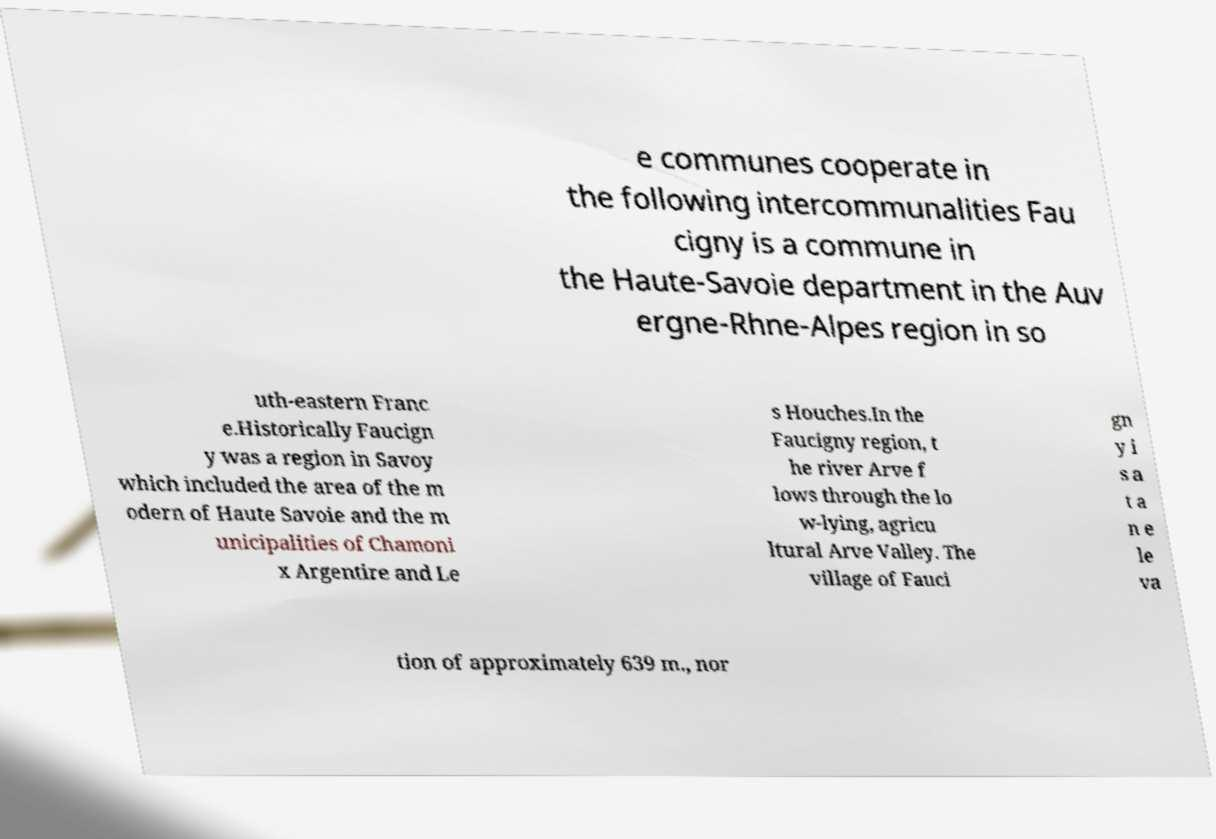Could you extract and type out the text from this image? e communes cooperate in the following intercommunalities Fau cigny is a commune in the Haute-Savoie department in the Auv ergne-Rhne-Alpes region in so uth-eastern Franc e.Historically Faucign y was a region in Savoy which included the area of the m odern of Haute Savoie and the m unicipalities of Chamoni x Argentire and Le s Houches.In the Faucigny region, t he river Arve f lows through the lo w-lying, agricu ltural Arve Valley. The village of Fauci gn y i s a t a n e le va tion of approximately 639 m., nor 